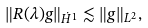<formula> <loc_0><loc_0><loc_500><loc_500>\| R ( \lambda ) g \| _ { \dot { H } ^ { 1 } } \lesssim \| g \| _ { L ^ { 2 } } ,</formula> 